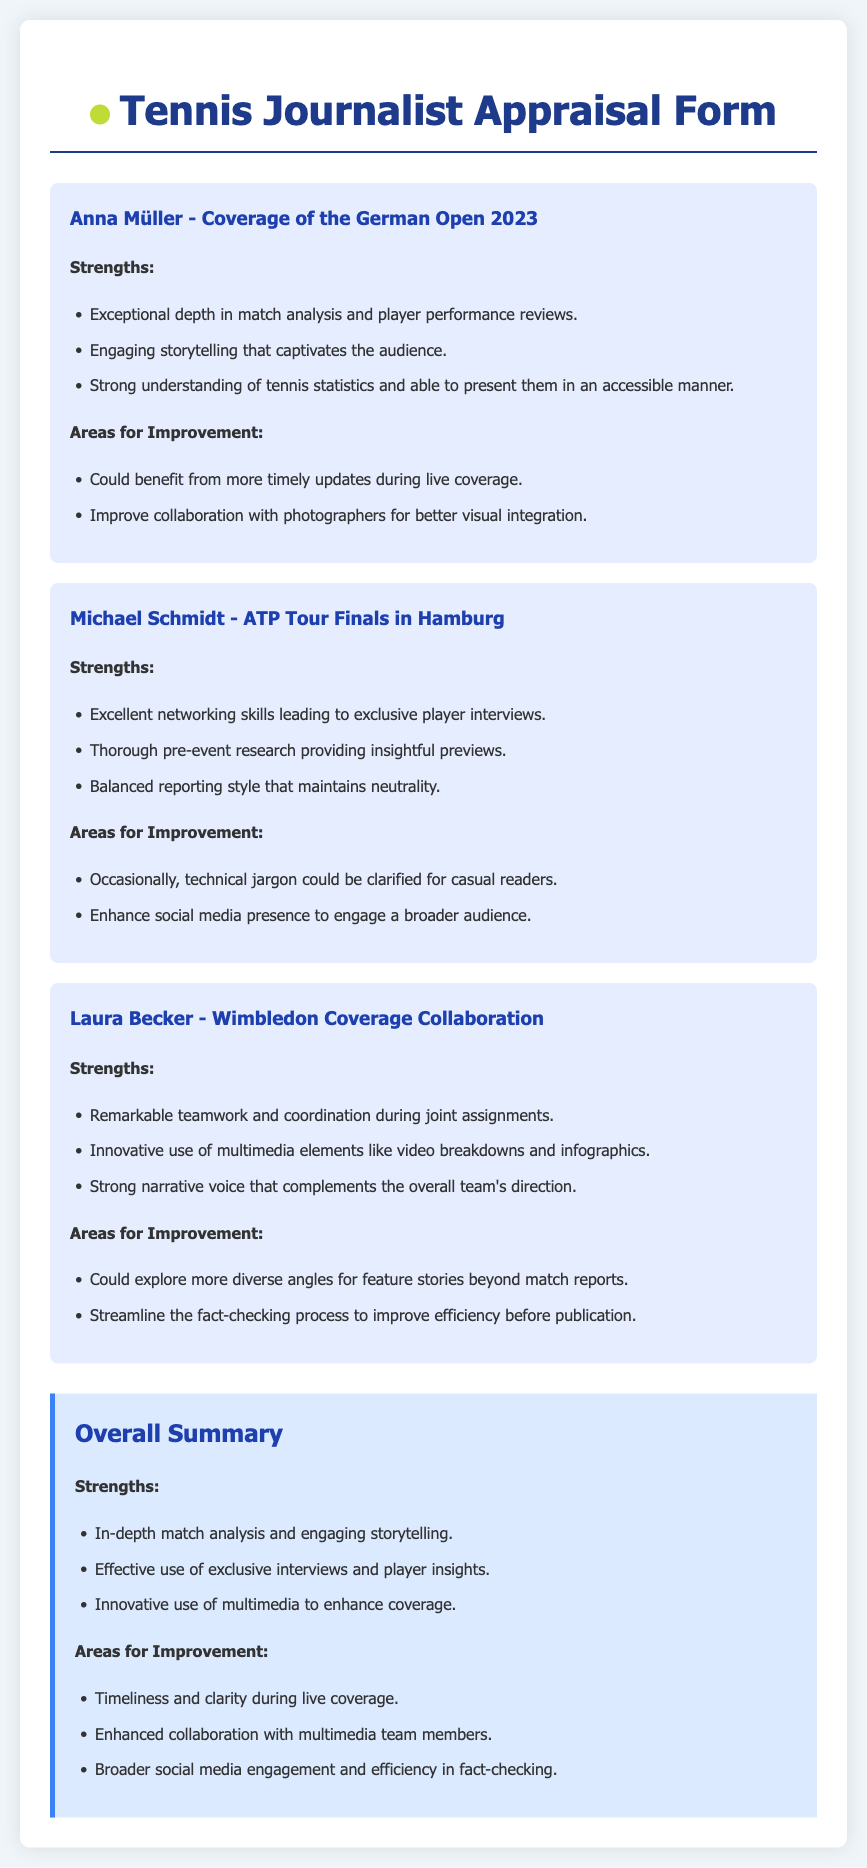What is Anna Müller's notable strength in coverage? Anna Müller's notable strength is described as having exceptional depth in match analysis and player performance reviews.
Answer: Exceptional depth in match analysis and player performance reviews Which event did Michael Schmidt cover? Michael Schmidt covered the ATP Tour Finals in Hamburg, as mentioned in the document.
Answer: ATP Tour Finals in Hamburg What area for improvement is suggested for Laura Becker? One area for improvement suggested for Laura Becker is to explore more diverse angles for feature stories beyond match reports.
Answer: Explore more diverse angles for feature stories beyond match reports How many strengths are listed in the overall summary? The overall summary lists three strengths under the strengths section.
Answer: Three What type of coverage did Laura Becker innovate? Laura Becker is noted for her innovative use of multimedia elements like video breakdowns and infographics.
Answer: Innovative use of multimedia elements Which journalist is noted for networking skills? The journalist noted for networking skills is Michael Schmidt.
Answer: Michael Schmidt What is a common area for improvement mentioned for all journalists? A common area for improvement mentioned for all journalists is enhanced collaboration with multimedia team members.
Answer: Enhanced collaboration with multimedia team members What report format does this document represent? This document represents an appraisal form, which includes feedback from fellow journalists on their collaborative projects.
Answer: Appraisal form 